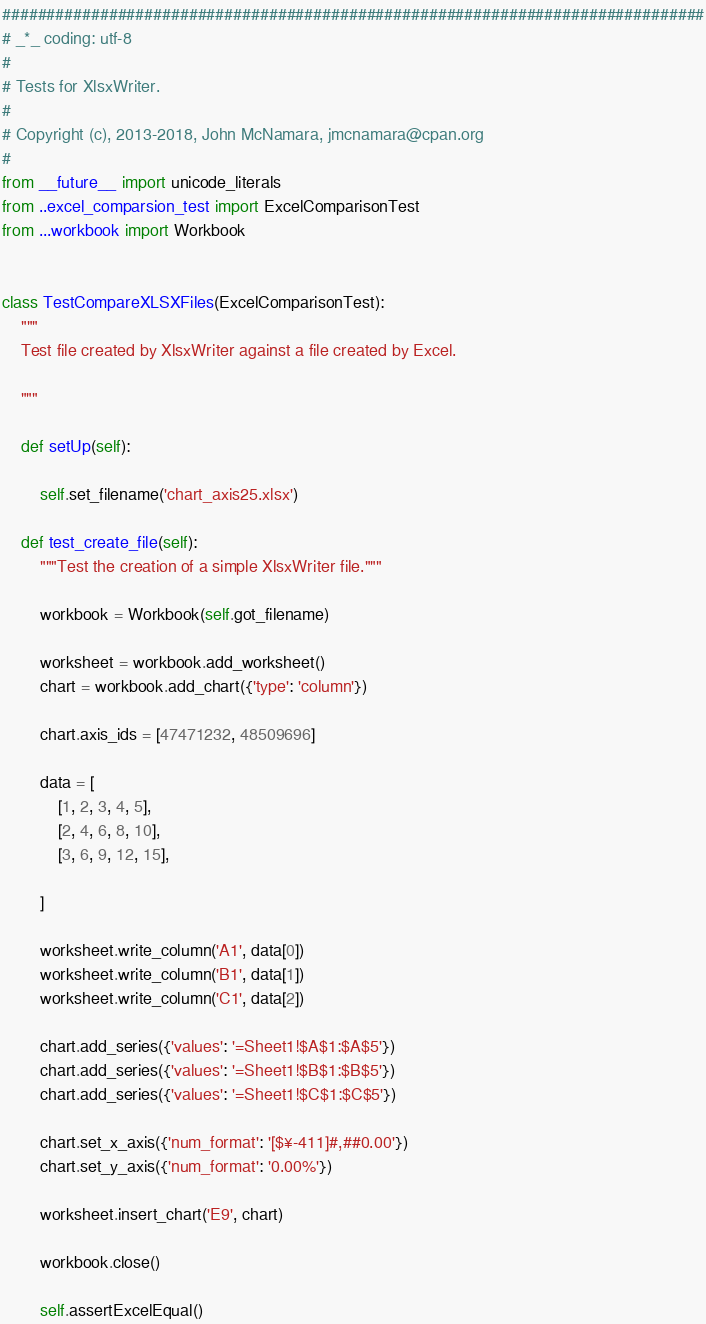Convert code to text. <code><loc_0><loc_0><loc_500><loc_500><_Python_>###############################################################################
# _*_ coding: utf-8
#
# Tests for XlsxWriter.
#
# Copyright (c), 2013-2018, John McNamara, jmcnamara@cpan.org
#
from __future__ import unicode_literals
from ..excel_comparsion_test import ExcelComparisonTest
from ...workbook import Workbook


class TestCompareXLSXFiles(ExcelComparisonTest):
    """
    Test file created by XlsxWriter against a file created by Excel.

    """

    def setUp(self):

        self.set_filename('chart_axis25.xlsx')

    def test_create_file(self):
        """Test the creation of a simple XlsxWriter file."""

        workbook = Workbook(self.got_filename)

        worksheet = workbook.add_worksheet()
        chart = workbook.add_chart({'type': 'column'})

        chart.axis_ids = [47471232, 48509696]

        data = [
            [1, 2, 3, 4, 5],
            [2, 4, 6, 8, 10],
            [3, 6, 9, 12, 15],

        ]

        worksheet.write_column('A1', data[0])
        worksheet.write_column('B1', data[1])
        worksheet.write_column('C1', data[2])

        chart.add_series({'values': '=Sheet1!$A$1:$A$5'})
        chart.add_series({'values': '=Sheet1!$B$1:$B$5'})
        chart.add_series({'values': '=Sheet1!$C$1:$C$5'})

        chart.set_x_axis({'num_format': '[$¥-411]#,##0.00'})
        chart.set_y_axis({'num_format': '0.00%'})

        worksheet.insert_chart('E9', chart)

        workbook.close()

        self.assertExcelEqual()
</code> 